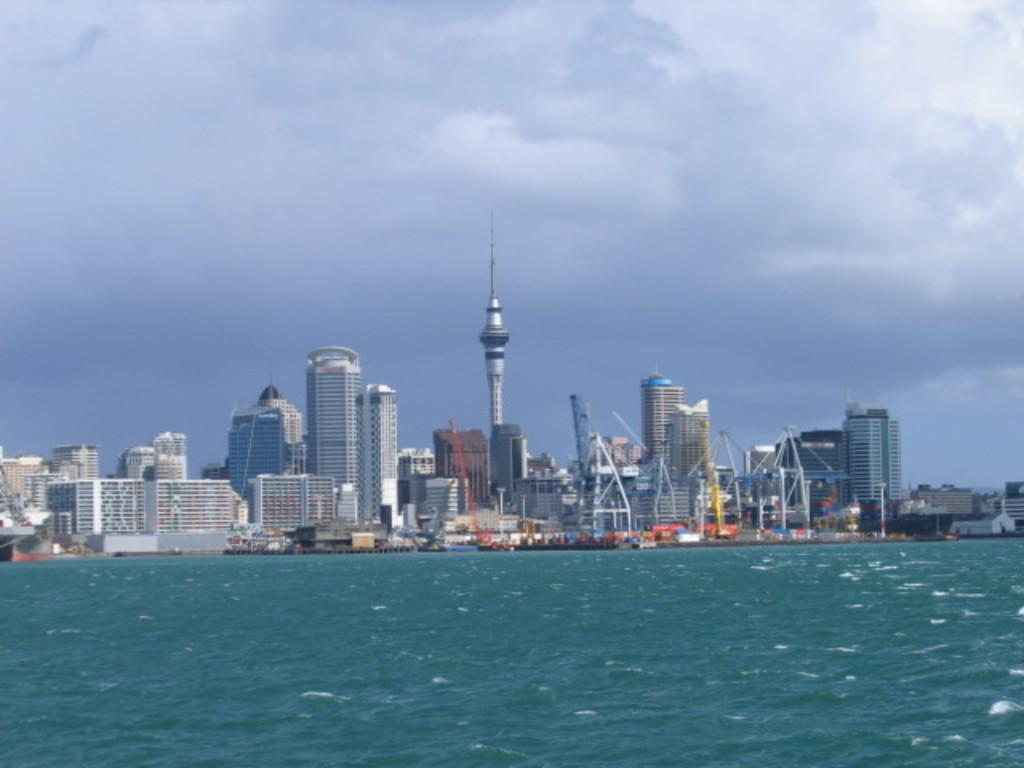What is the main subject in the center of the image? There is water in the center of the image. What can be seen in the background of the image? The sky, clouds, buildings, towers, poles, and boats are present in the background of the image. Where is the bomb located in the image? There is no bomb present in the image. What type of yak can be seen grazing on the land in the image? There is no yak or land present in the image; it features water and various elements in the background. 